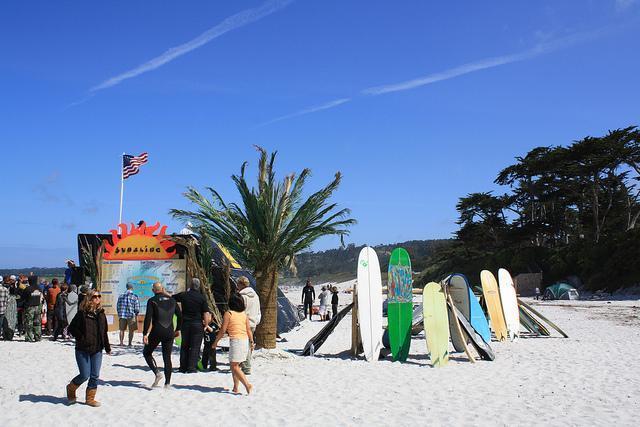How many surfboards are in the photo?
Give a very brief answer. 2. How many people are in the photo?
Give a very brief answer. 4. 